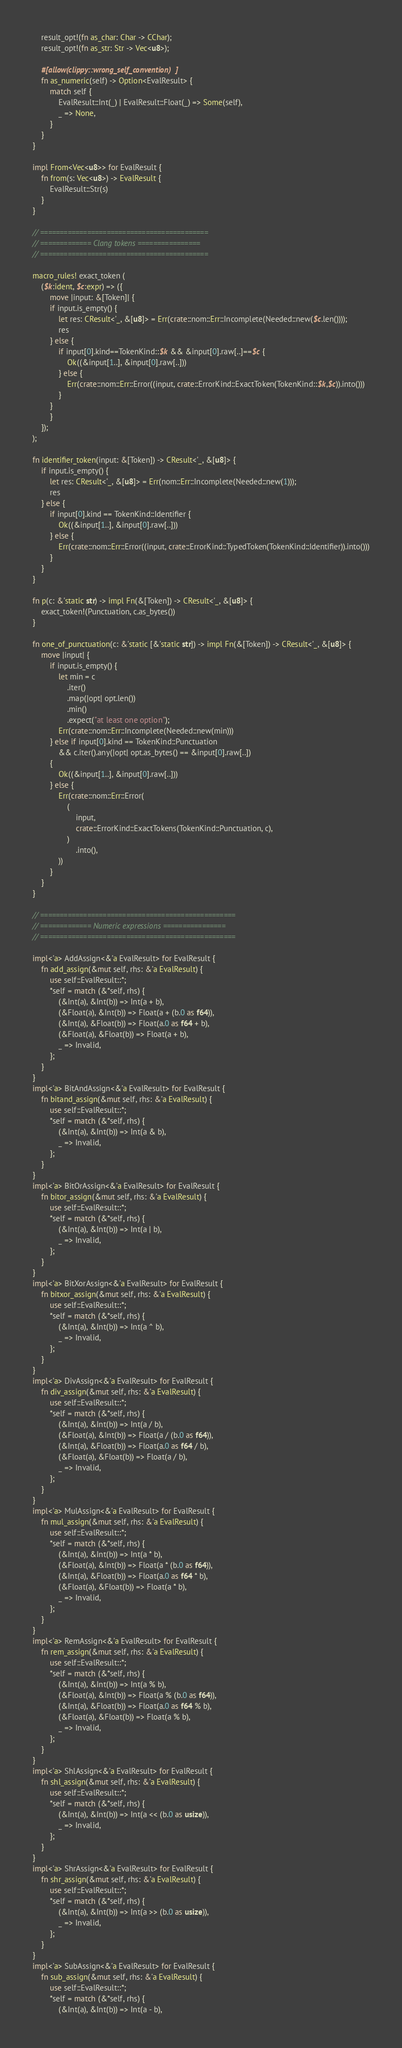<code> <loc_0><loc_0><loc_500><loc_500><_Rust_>    result_opt!(fn as_char: Char -> CChar);
    result_opt!(fn as_str: Str -> Vec<u8>);

    #[allow(clippy::wrong_self_convention)]
    fn as_numeric(self) -> Option<EvalResult> {
        match self {
            EvalResult::Int(_) | EvalResult::Float(_) => Some(self),
            _ => None,
        }
    }
}

impl From<Vec<u8>> for EvalResult {
    fn from(s: Vec<u8>) -> EvalResult {
        EvalResult::Str(s)
    }
}

// ===========================================
// ============= Clang tokens ================
// ===========================================

macro_rules! exact_token (
	($k:ident, $c:expr) => ({
        move |input: &[Token]| {
		if input.is_empty() {
			let res: CResult<'_, &[u8]> = Err(crate::nom::Err::Incomplete(Needed::new($c.len())));
			res
		} else {
			if input[0].kind==TokenKind::$k && &input[0].raw[..]==$c {
				Ok((&input[1..], &input[0].raw[..]))
			} else {
				Err(crate::nom::Err::Error((input, crate::ErrorKind::ExactToken(TokenKind::$k,$c)).into()))
			}
		}
        }
	});
);

fn identifier_token(input: &[Token]) -> CResult<'_, &[u8]> {
    if input.is_empty() {
        let res: CResult<'_, &[u8]> = Err(nom::Err::Incomplete(Needed::new(1)));
        res
    } else {
        if input[0].kind == TokenKind::Identifier {
            Ok((&input[1..], &input[0].raw[..]))
        } else {
            Err(crate::nom::Err::Error((input, crate::ErrorKind::TypedToken(TokenKind::Identifier)).into()))
        }
    }
}

fn p(c: &'static str) -> impl Fn(&[Token]) -> CResult<'_, &[u8]> {
    exact_token!(Punctuation, c.as_bytes())
}

fn one_of_punctuation(c: &'static [&'static str]) -> impl Fn(&[Token]) -> CResult<'_, &[u8]> {
    move |input| {
        if input.is_empty() {
            let min = c
                .iter()
                .map(|opt| opt.len())
                .min()
                .expect("at least one option");
            Err(crate::nom::Err::Incomplete(Needed::new(min)))
        } else if input[0].kind == TokenKind::Punctuation
            && c.iter().any(|opt| opt.as_bytes() == &input[0].raw[..])
        {
            Ok((&input[1..], &input[0].raw[..]))
        } else {
            Err(crate::nom::Err::Error(
                (
                    input,
                    crate::ErrorKind::ExactTokens(TokenKind::Punctuation, c),
                )
                    .into(),
            ))
        }
    }
}

// ==================================================
// ============= Numeric expressions ================
// ==================================================

impl<'a> AddAssign<&'a EvalResult> for EvalResult {
    fn add_assign(&mut self, rhs: &'a EvalResult) {
        use self::EvalResult::*;
        *self = match (&*self, rhs) {
            (&Int(a), &Int(b)) => Int(a + b),
            (&Float(a), &Int(b)) => Float(a + (b.0 as f64)),
            (&Int(a), &Float(b)) => Float(a.0 as f64 + b),
            (&Float(a), &Float(b)) => Float(a + b),
            _ => Invalid,
        };
    }
}
impl<'a> BitAndAssign<&'a EvalResult> for EvalResult {
    fn bitand_assign(&mut self, rhs: &'a EvalResult) {
        use self::EvalResult::*;
        *self = match (&*self, rhs) {
            (&Int(a), &Int(b)) => Int(a & b),
            _ => Invalid,
        };
    }
}
impl<'a> BitOrAssign<&'a EvalResult> for EvalResult {
    fn bitor_assign(&mut self, rhs: &'a EvalResult) {
        use self::EvalResult::*;
        *self = match (&*self, rhs) {
            (&Int(a), &Int(b)) => Int(a | b),
            _ => Invalid,
        };
    }
}
impl<'a> BitXorAssign<&'a EvalResult> for EvalResult {
    fn bitxor_assign(&mut self, rhs: &'a EvalResult) {
        use self::EvalResult::*;
        *self = match (&*self, rhs) {
            (&Int(a), &Int(b)) => Int(a ^ b),
            _ => Invalid,
        };
    }
}
impl<'a> DivAssign<&'a EvalResult> for EvalResult {
    fn div_assign(&mut self, rhs: &'a EvalResult) {
        use self::EvalResult::*;
        *self = match (&*self, rhs) {
            (&Int(a), &Int(b)) => Int(a / b),
            (&Float(a), &Int(b)) => Float(a / (b.0 as f64)),
            (&Int(a), &Float(b)) => Float(a.0 as f64 / b),
            (&Float(a), &Float(b)) => Float(a / b),
            _ => Invalid,
        };
    }
}
impl<'a> MulAssign<&'a EvalResult> for EvalResult {
    fn mul_assign(&mut self, rhs: &'a EvalResult) {
        use self::EvalResult::*;
        *self = match (&*self, rhs) {
            (&Int(a), &Int(b)) => Int(a * b),
            (&Float(a), &Int(b)) => Float(a * (b.0 as f64)),
            (&Int(a), &Float(b)) => Float(a.0 as f64 * b),
            (&Float(a), &Float(b)) => Float(a * b),
            _ => Invalid,
        };
    }
}
impl<'a> RemAssign<&'a EvalResult> for EvalResult {
    fn rem_assign(&mut self, rhs: &'a EvalResult) {
        use self::EvalResult::*;
        *self = match (&*self, rhs) {
            (&Int(a), &Int(b)) => Int(a % b),
            (&Float(a), &Int(b)) => Float(a % (b.0 as f64)),
            (&Int(a), &Float(b)) => Float(a.0 as f64 % b),
            (&Float(a), &Float(b)) => Float(a % b),
            _ => Invalid,
        };
    }
}
impl<'a> ShlAssign<&'a EvalResult> for EvalResult {
    fn shl_assign(&mut self, rhs: &'a EvalResult) {
        use self::EvalResult::*;
        *self = match (&*self, rhs) {
            (&Int(a), &Int(b)) => Int(a << (b.0 as usize)),
            _ => Invalid,
        };
    }
}
impl<'a> ShrAssign<&'a EvalResult> for EvalResult {
    fn shr_assign(&mut self, rhs: &'a EvalResult) {
        use self::EvalResult::*;
        *self = match (&*self, rhs) {
            (&Int(a), &Int(b)) => Int(a >> (b.0 as usize)),
            _ => Invalid,
        };
    }
}
impl<'a> SubAssign<&'a EvalResult> for EvalResult {
    fn sub_assign(&mut self, rhs: &'a EvalResult) {
        use self::EvalResult::*;
        *self = match (&*self, rhs) {
            (&Int(a), &Int(b)) => Int(a - b),</code> 